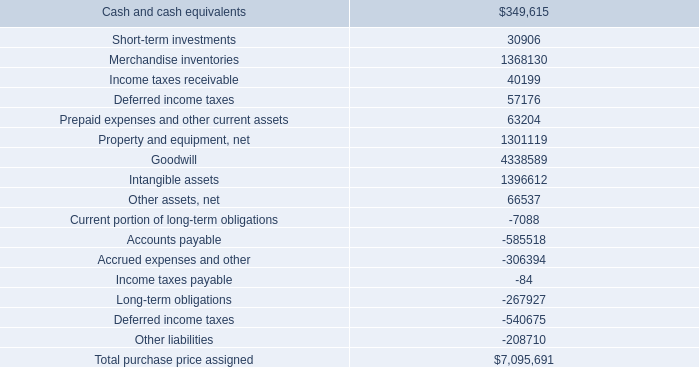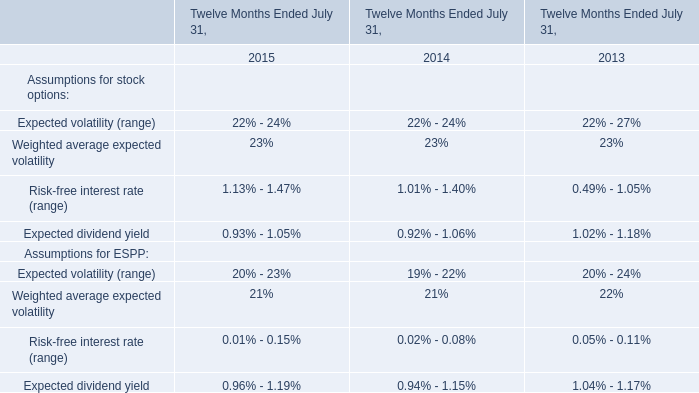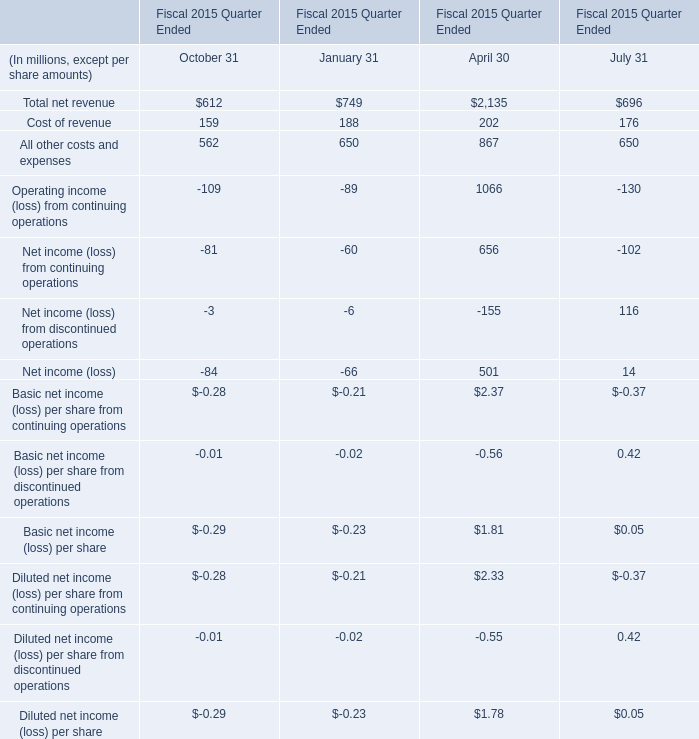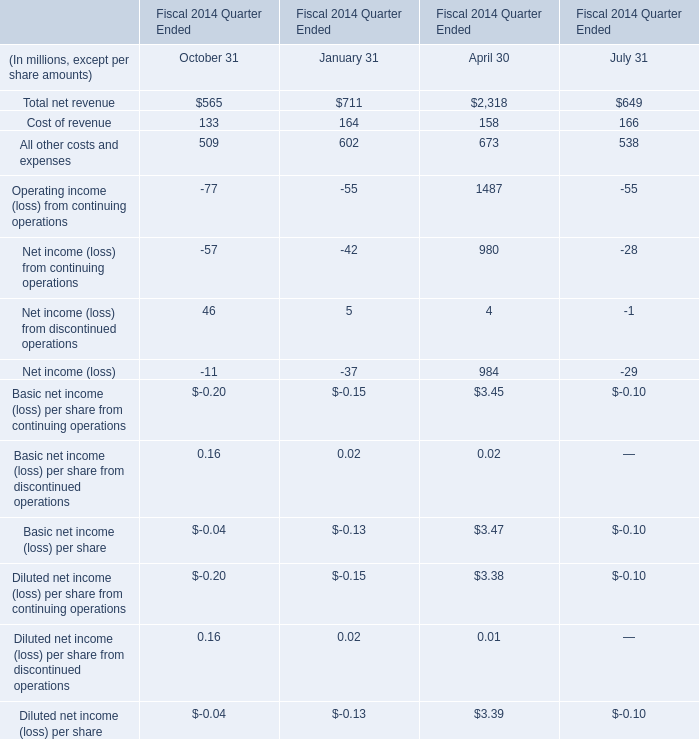What was the total amount of the Basic net income (loss) per share from continuing operations in the sections where Total net revenue greater than 0? (in million) 
Computations: (((-0.20 - 0.15) + 3.45) - 0.10)
Answer: 3.0. 